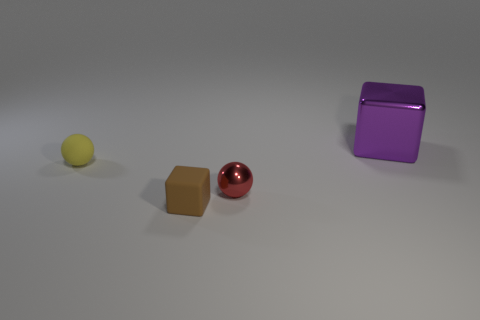Add 4 tiny metallic spheres. How many objects exist? 8 Subtract all tiny yellow matte things. Subtract all yellow rubber things. How many objects are left? 2 Add 2 brown objects. How many brown objects are left? 3 Add 1 purple rubber balls. How many purple rubber balls exist? 1 Subtract 0 cyan spheres. How many objects are left? 4 